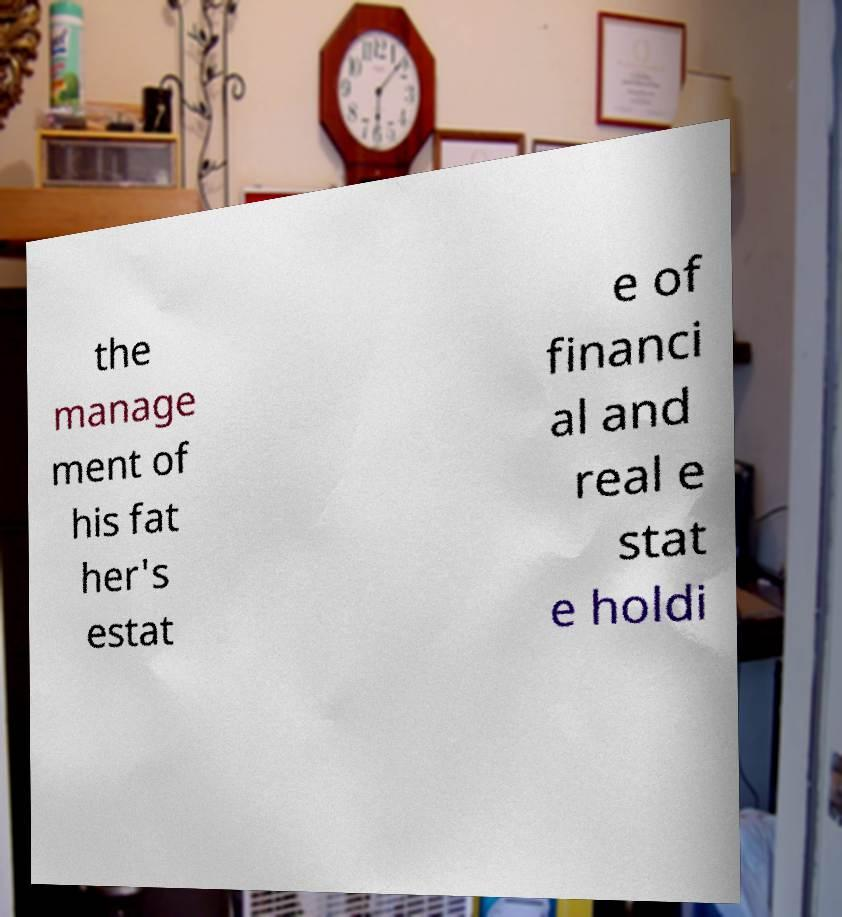For documentation purposes, I need the text within this image transcribed. Could you provide that? the manage ment of his fat her's estat e of financi al and real e stat e holdi 